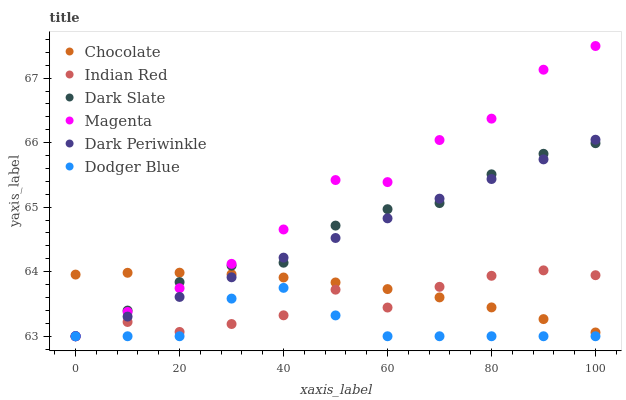Does Dodger Blue have the minimum area under the curve?
Answer yes or no. Yes. Does Magenta have the maximum area under the curve?
Answer yes or no. Yes. Does Dark Slate have the minimum area under the curve?
Answer yes or no. No. Does Dark Slate have the maximum area under the curve?
Answer yes or no. No. Is Dark Periwinkle the smoothest?
Answer yes or no. Yes. Is Magenta the roughest?
Answer yes or no. Yes. Is Dark Slate the smoothest?
Answer yes or no. No. Is Dark Slate the roughest?
Answer yes or no. No. Does Dark Slate have the lowest value?
Answer yes or no. Yes. Does Magenta have the highest value?
Answer yes or no. Yes. Does Dark Slate have the highest value?
Answer yes or no. No. Is Dodger Blue less than Chocolate?
Answer yes or no. Yes. Is Chocolate greater than Dodger Blue?
Answer yes or no. Yes. Does Dark Slate intersect Chocolate?
Answer yes or no. Yes. Is Dark Slate less than Chocolate?
Answer yes or no. No. Is Dark Slate greater than Chocolate?
Answer yes or no. No. Does Dodger Blue intersect Chocolate?
Answer yes or no. No. 